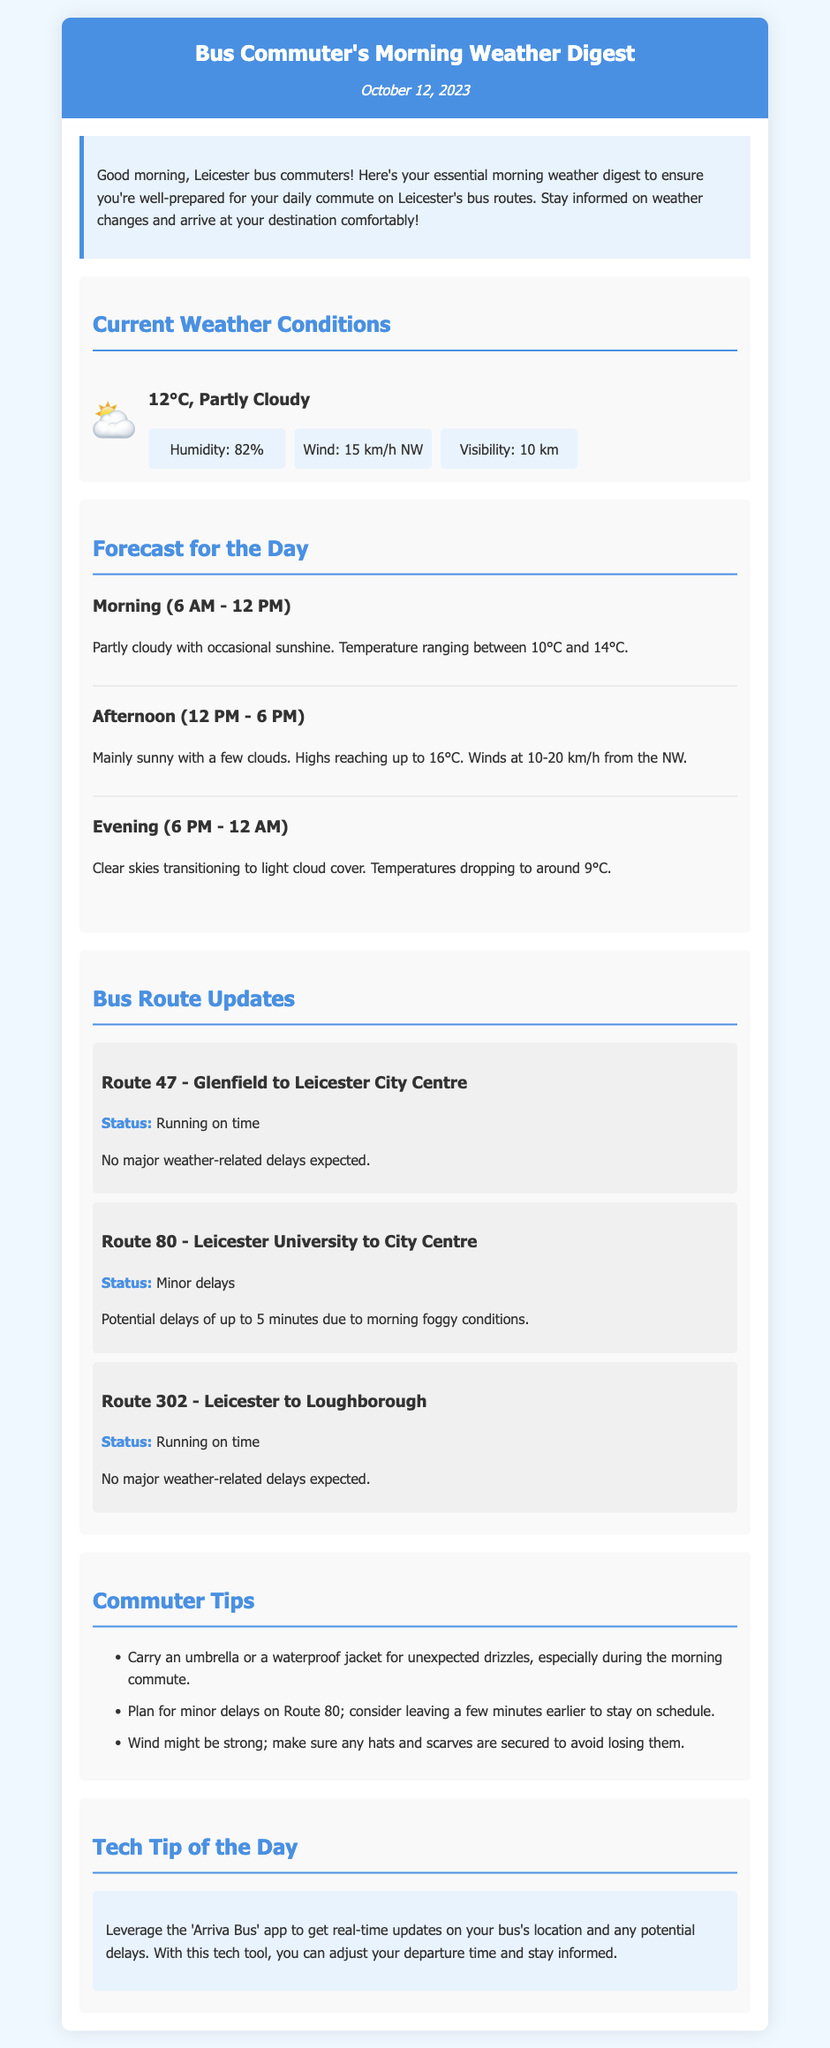What is the current temperature? The current temperature is listed in the weather conditions section of the report.
Answer: 12°C What is the weather status for Route 47? The route status is mentioned under the bus route updates section, specifically for Route 47.
Answer: Running on time What is the humidity percentage? The humidity percentage is provided in the weather details section of the current weather conditions.
Answer: 82% What are the expected afternoon temperatures? The afternoon temperatures are specified in the forecast for the day section.
Answer: Highs reaching up to 16°C What tip is recommended for unexpected drizzles? The commuter tips section includes suggestions for managing unexpected weather.
Answer: Carry an umbrella or a waterproof jacket What is the status of Route 80? The status for Route 80 is noted in the bus route updates section detailing its current condition.
Answer: Minor delays What is the visibility distance? The visibility distance is provided within the weather details of the current weather conditions.
Answer: 10 km What technology should commuters use for real-time updates? The tech tip section advises on a specific app for receiving real-time bus updates.
Answer: Arriva Bus app 